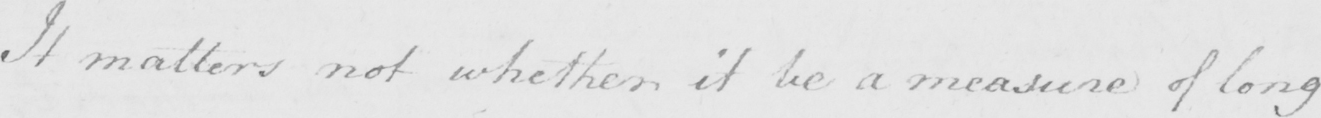Can you read and transcribe this handwriting? It matters not whether it be a measure of long 